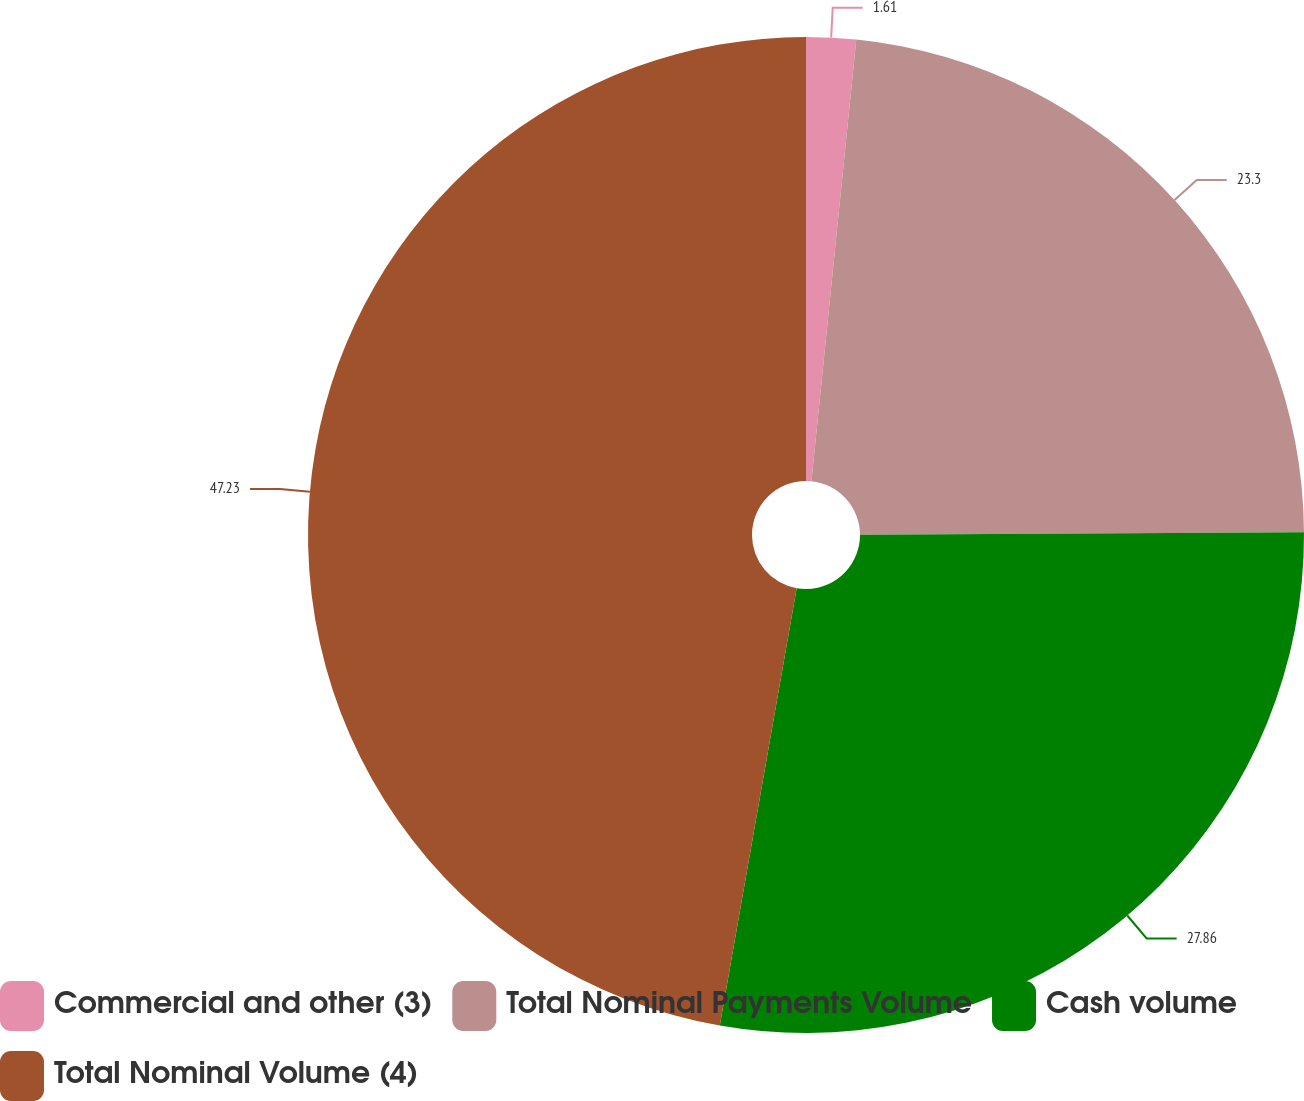Convert chart to OTSL. <chart><loc_0><loc_0><loc_500><loc_500><pie_chart><fcel>Commercial and other (3)<fcel>Total Nominal Payments Volume<fcel>Cash volume<fcel>Total Nominal Volume (4)<nl><fcel>1.61%<fcel>23.3%<fcel>27.86%<fcel>47.23%<nl></chart> 